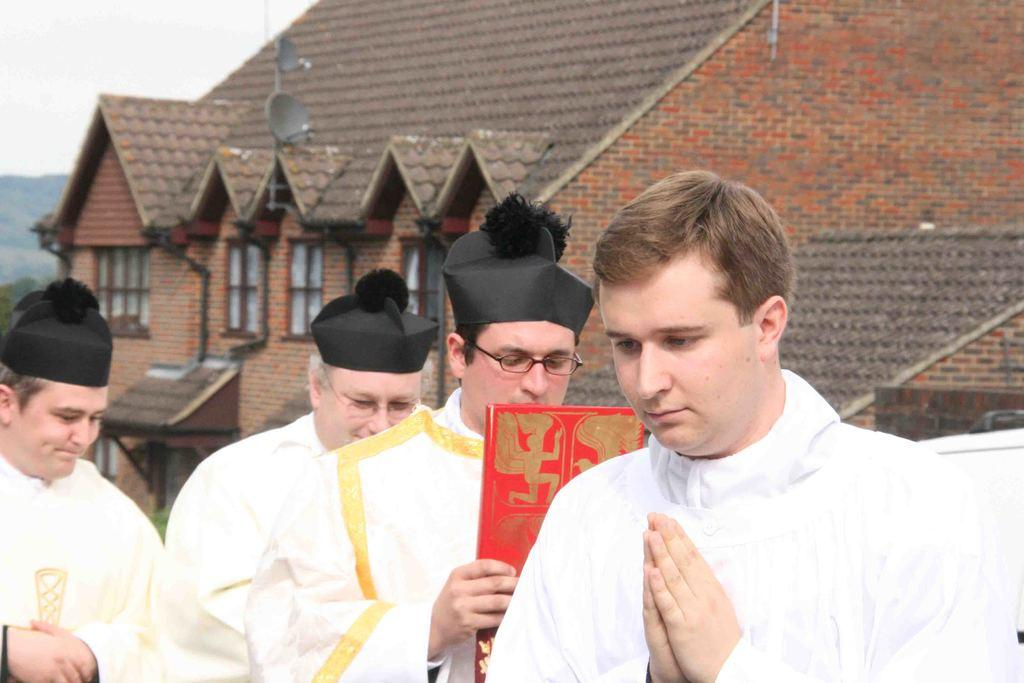Where is the man located in the image? The man is on the right side of the image. How many men are on the left side of the image? There are three men on the left side of the image. What can be seen in the background of the image? There is a house, windows, antennas, a roof, hills, and the sky visible in the background of the image. What type of discussion is taking place between the men in the image? There is no indication of a discussion taking place between the men in the image. How does the man on the right side of the image grip the object in his hand? There is no object visible in the man's hand in the image. 